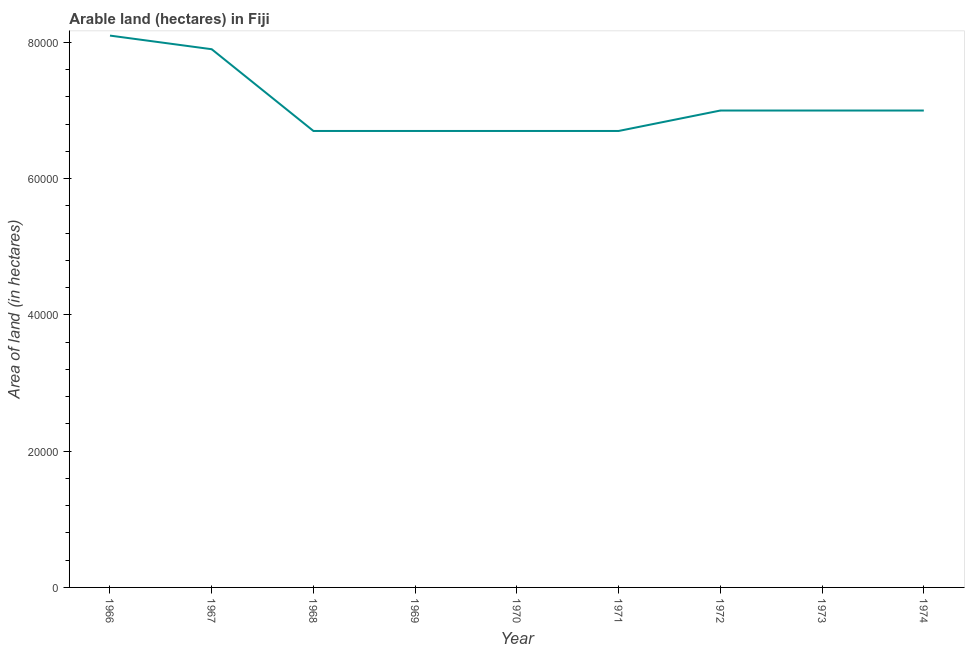What is the area of land in 1973?
Ensure brevity in your answer.  7.00e+04. Across all years, what is the maximum area of land?
Give a very brief answer. 8.10e+04. Across all years, what is the minimum area of land?
Ensure brevity in your answer.  6.70e+04. In which year was the area of land maximum?
Your answer should be compact. 1966. In which year was the area of land minimum?
Make the answer very short. 1968. What is the sum of the area of land?
Your response must be concise. 6.38e+05. What is the difference between the area of land in 1968 and 1972?
Keep it short and to the point. -3000. What is the average area of land per year?
Your answer should be very brief. 7.09e+04. In how many years, is the area of land greater than 52000 hectares?
Your answer should be very brief. 9. Do a majority of the years between 1968 and 1970 (inclusive) have area of land greater than 44000 hectares?
Your response must be concise. Yes. What is the ratio of the area of land in 1971 to that in 1974?
Offer a terse response. 0.96. Is the area of land in 1969 less than that in 1973?
Provide a short and direct response. Yes. Is the sum of the area of land in 1971 and 1974 greater than the maximum area of land across all years?
Your response must be concise. Yes. What is the difference between the highest and the lowest area of land?
Offer a terse response. 1.40e+04. In how many years, is the area of land greater than the average area of land taken over all years?
Your answer should be very brief. 2. How many lines are there?
Your answer should be compact. 1. What is the difference between two consecutive major ticks on the Y-axis?
Provide a succinct answer. 2.00e+04. Are the values on the major ticks of Y-axis written in scientific E-notation?
Your answer should be compact. No. Does the graph contain any zero values?
Give a very brief answer. No. What is the title of the graph?
Give a very brief answer. Arable land (hectares) in Fiji. What is the label or title of the Y-axis?
Ensure brevity in your answer.  Area of land (in hectares). What is the Area of land (in hectares) in 1966?
Make the answer very short. 8.10e+04. What is the Area of land (in hectares) in 1967?
Make the answer very short. 7.90e+04. What is the Area of land (in hectares) in 1968?
Provide a succinct answer. 6.70e+04. What is the Area of land (in hectares) of 1969?
Give a very brief answer. 6.70e+04. What is the Area of land (in hectares) in 1970?
Give a very brief answer. 6.70e+04. What is the Area of land (in hectares) of 1971?
Your answer should be compact. 6.70e+04. What is the Area of land (in hectares) of 1972?
Offer a terse response. 7.00e+04. What is the Area of land (in hectares) of 1974?
Keep it short and to the point. 7.00e+04. What is the difference between the Area of land (in hectares) in 1966 and 1967?
Provide a short and direct response. 2000. What is the difference between the Area of land (in hectares) in 1966 and 1968?
Make the answer very short. 1.40e+04. What is the difference between the Area of land (in hectares) in 1966 and 1969?
Your answer should be very brief. 1.40e+04. What is the difference between the Area of land (in hectares) in 1966 and 1970?
Give a very brief answer. 1.40e+04. What is the difference between the Area of land (in hectares) in 1966 and 1971?
Provide a short and direct response. 1.40e+04. What is the difference between the Area of land (in hectares) in 1966 and 1972?
Offer a very short reply. 1.10e+04. What is the difference between the Area of land (in hectares) in 1966 and 1973?
Provide a succinct answer. 1.10e+04. What is the difference between the Area of land (in hectares) in 1966 and 1974?
Offer a very short reply. 1.10e+04. What is the difference between the Area of land (in hectares) in 1967 and 1968?
Keep it short and to the point. 1.20e+04. What is the difference between the Area of land (in hectares) in 1967 and 1969?
Provide a succinct answer. 1.20e+04. What is the difference between the Area of land (in hectares) in 1967 and 1970?
Keep it short and to the point. 1.20e+04. What is the difference between the Area of land (in hectares) in 1967 and 1971?
Your answer should be compact. 1.20e+04. What is the difference between the Area of land (in hectares) in 1967 and 1972?
Provide a short and direct response. 9000. What is the difference between the Area of land (in hectares) in 1967 and 1973?
Your response must be concise. 9000. What is the difference between the Area of land (in hectares) in 1967 and 1974?
Ensure brevity in your answer.  9000. What is the difference between the Area of land (in hectares) in 1968 and 1970?
Offer a terse response. 0. What is the difference between the Area of land (in hectares) in 1968 and 1971?
Your answer should be compact. 0. What is the difference between the Area of land (in hectares) in 1968 and 1972?
Your answer should be very brief. -3000. What is the difference between the Area of land (in hectares) in 1968 and 1973?
Your response must be concise. -3000. What is the difference between the Area of land (in hectares) in 1968 and 1974?
Your answer should be compact. -3000. What is the difference between the Area of land (in hectares) in 1969 and 1970?
Provide a succinct answer. 0. What is the difference between the Area of land (in hectares) in 1969 and 1971?
Your response must be concise. 0. What is the difference between the Area of land (in hectares) in 1969 and 1972?
Your answer should be compact. -3000. What is the difference between the Area of land (in hectares) in 1969 and 1973?
Make the answer very short. -3000. What is the difference between the Area of land (in hectares) in 1969 and 1974?
Your answer should be very brief. -3000. What is the difference between the Area of land (in hectares) in 1970 and 1972?
Provide a succinct answer. -3000. What is the difference between the Area of land (in hectares) in 1970 and 1973?
Keep it short and to the point. -3000. What is the difference between the Area of land (in hectares) in 1970 and 1974?
Keep it short and to the point. -3000. What is the difference between the Area of land (in hectares) in 1971 and 1972?
Offer a terse response. -3000. What is the difference between the Area of land (in hectares) in 1971 and 1973?
Make the answer very short. -3000. What is the difference between the Area of land (in hectares) in 1971 and 1974?
Offer a very short reply. -3000. What is the difference between the Area of land (in hectares) in 1972 and 1974?
Your response must be concise. 0. What is the ratio of the Area of land (in hectares) in 1966 to that in 1968?
Your answer should be compact. 1.21. What is the ratio of the Area of land (in hectares) in 1966 to that in 1969?
Make the answer very short. 1.21. What is the ratio of the Area of land (in hectares) in 1966 to that in 1970?
Provide a short and direct response. 1.21. What is the ratio of the Area of land (in hectares) in 1966 to that in 1971?
Make the answer very short. 1.21. What is the ratio of the Area of land (in hectares) in 1966 to that in 1972?
Provide a succinct answer. 1.16. What is the ratio of the Area of land (in hectares) in 1966 to that in 1973?
Provide a succinct answer. 1.16. What is the ratio of the Area of land (in hectares) in 1966 to that in 1974?
Give a very brief answer. 1.16. What is the ratio of the Area of land (in hectares) in 1967 to that in 1968?
Give a very brief answer. 1.18. What is the ratio of the Area of land (in hectares) in 1967 to that in 1969?
Your answer should be compact. 1.18. What is the ratio of the Area of land (in hectares) in 1967 to that in 1970?
Keep it short and to the point. 1.18. What is the ratio of the Area of land (in hectares) in 1967 to that in 1971?
Your answer should be very brief. 1.18. What is the ratio of the Area of land (in hectares) in 1967 to that in 1972?
Make the answer very short. 1.13. What is the ratio of the Area of land (in hectares) in 1967 to that in 1973?
Offer a terse response. 1.13. What is the ratio of the Area of land (in hectares) in 1967 to that in 1974?
Provide a short and direct response. 1.13. What is the ratio of the Area of land (in hectares) in 1968 to that in 1969?
Offer a terse response. 1. What is the ratio of the Area of land (in hectares) in 1968 to that in 1971?
Offer a very short reply. 1. What is the ratio of the Area of land (in hectares) in 1968 to that in 1973?
Your answer should be compact. 0.96. What is the ratio of the Area of land (in hectares) in 1968 to that in 1974?
Offer a very short reply. 0.96. What is the ratio of the Area of land (in hectares) in 1969 to that in 1971?
Make the answer very short. 1. What is the ratio of the Area of land (in hectares) in 1969 to that in 1972?
Offer a terse response. 0.96. What is the ratio of the Area of land (in hectares) in 1970 to that in 1972?
Your response must be concise. 0.96. What is the ratio of the Area of land (in hectares) in 1970 to that in 1973?
Ensure brevity in your answer.  0.96. What is the ratio of the Area of land (in hectares) in 1970 to that in 1974?
Provide a short and direct response. 0.96. What is the ratio of the Area of land (in hectares) in 1971 to that in 1972?
Your response must be concise. 0.96. What is the ratio of the Area of land (in hectares) in 1971 to that in 1973?
Offer a very short reply. 0.96. What is the ratio of the Area of land (in hectares) in 1972 to that in 1974?
Offer a terse response. 1. 